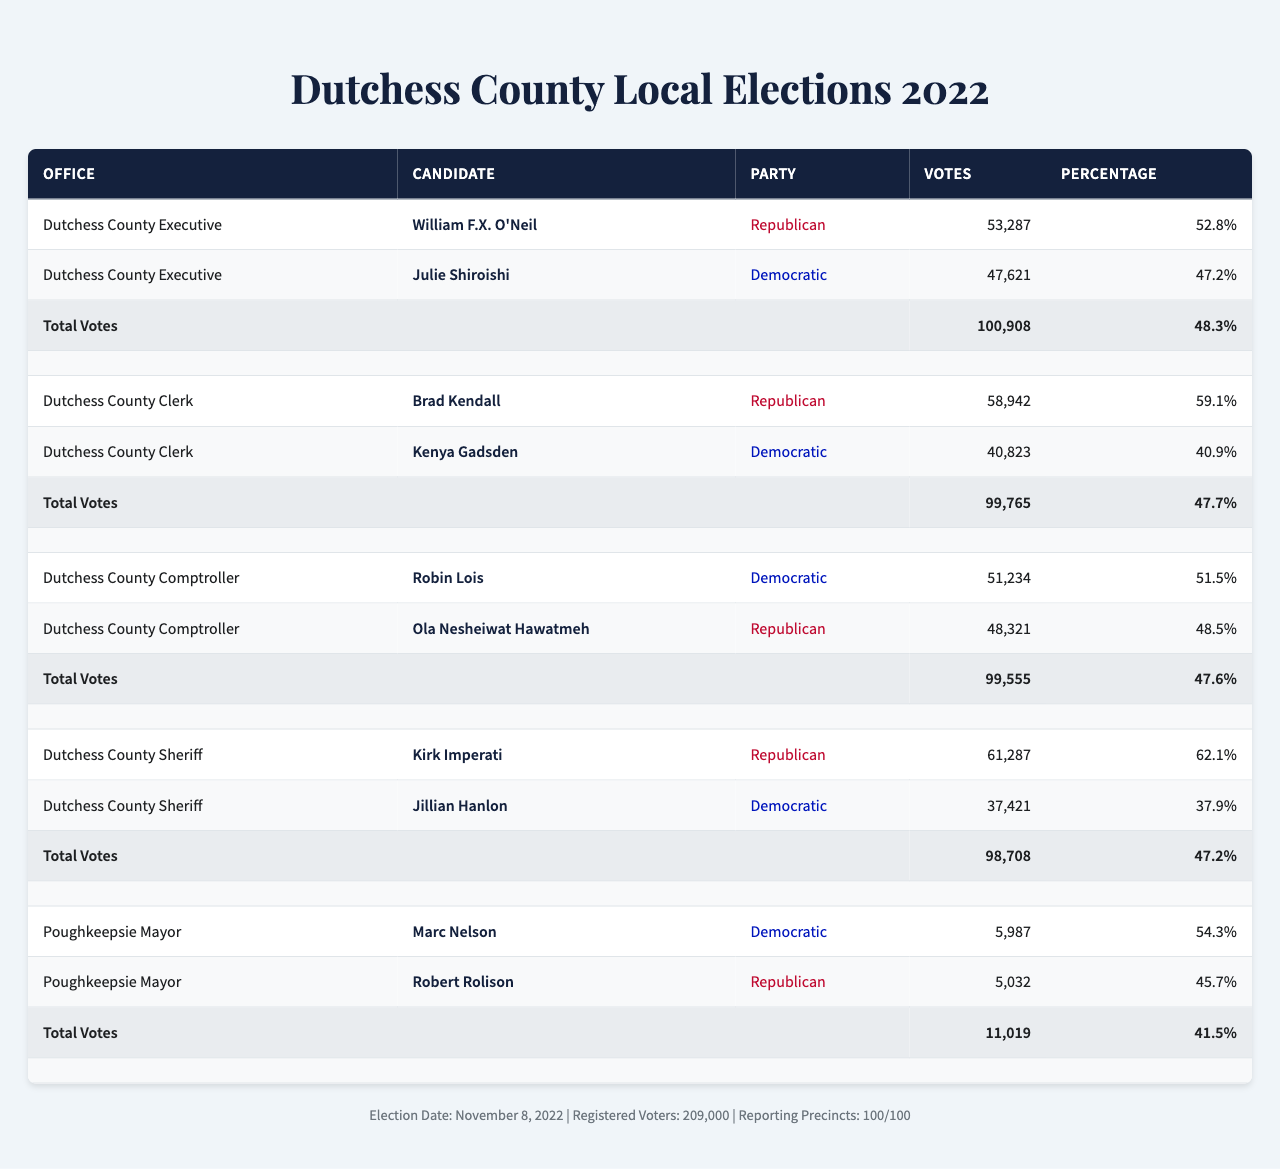What was the total number of votes cast in the Dutchess County Executive election? The table lists the total votes for the Dutchess County Executive election as 100,908 under the corresponding office.
Answer: 100,908 Which candidate received the highest number of votes in the Dutchess County Sheriff election? In the Dutchess County Sheriff election, Kirk Imperati received 61,287 votes, which is higher than Jillian Hanlon’s 37,421 votes.
Answer: Kirk Imperati What was the voter turnout percentage for the Poughkeepsie Mayor election? The table indicates that the voter turnout for the Poughkeepsie Mayor election was 41.5%, as shown in the row for that specific office.
Answer: 41.5% Who won the Dutchess County Clerk position and by what percentage? Brad Kendall won the Dutchess County Clerk position with 59.1% of the total votes, which is found in the candidates' section of that election.
Answer: Brad Kendall, 59.1% What is the total number of votes cast for all candidates in the Dutchess County Comptroller election? The total votes for the Dutchess County Comptroller election is listed as 99,555, found in the total votes row for that election.
Answer: 99,555 How many more votes did William F.X. O'Neil receive compared to Julie Shiroishi in the Dutchess County Executive election? William F.X. O'Neil received 53,287 votes, and Julie Shiroishi received 47,621 votes. The difference is calculated as 53,287 - 47,621 = 5,666.
Answer: 5,666 Which party had the most candidates winning across all elections listed? By analyzing the results, Republicans won the positions of Dutchess County Executive, Clerk, and Sheriff, while Democrats won the Comptroller and Poughkeepsie Mayor. Thus, Republicans won 3 positions and Democrats won 2 positions.
Answer: Republicans What is the average percentage of votes received by Democratic candidates across all elections? The percentages for Democratic candidates are 47.2% (Shiroishi), 40.9% (Gadsden), 51.5% (Lois), 37.9% (Hanlon), and 54.3% (Nelson). The total is 232.8%. Divided by the 5 candidates, the average is 232.8% / 5 = 46.56%.
Answer: 46.56% Did any of the elections have a voter turnout of less than 45%? The voter turnout for all elections are 48.3%, 47.7%, 47.6%, 47.2%, and 41.5%. Only the Poughkeepsie Mayor election had a turnout below 45%.
Answer: Yes Which candidate received the lowest number of votes in the elections listed? Marc Nelson received 5,987 votes, which is the lowest compared to all other candidates' vote counts in the table.
Answer: Marc Nelson 